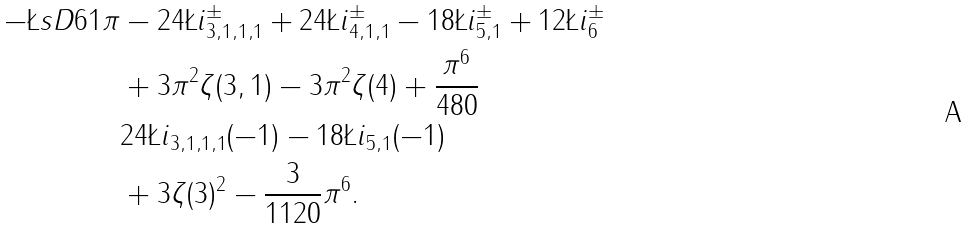Convert formula to latex. <formula><loc_0><loc_0><loc_500><loc_500>- \L s D { 6 } { 1 } { \pi } & - 2 4 \L i ^ { \pm } _ { 3 , 1 , 1 , 1 } + 2 4 \L i ^ { \pm } _ { 4 , 1 , 1 } - 1 8 \L i ^ { \pm } _ { 5 , 1 } + 1 2 \L i ^ { \pm } _ { 6 } \\ & + 3 \pi ^ { 2 } \zeta ( 3 , 1 ) - 3 \pi ^ { 2 } \zeta ( 4 ) + \frac { \pi ^ { 6 } } { 4 8 0 } \\ & 2 4 \L i _ { 3 , 1 , 1 , 1 } ( - 1 ) - 1 8 \L i _ { 5 , 1 } ( - 1 ) \\ & + 3 \zeta ( 3 ) ^ { 2 } - \frac { 3 } { 1 1 2 0 } \pi ^ { 6 } .</formula> 